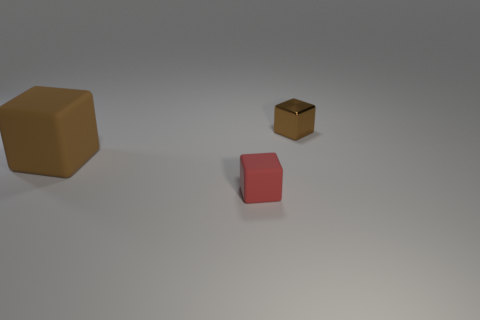Add 3 tiny red rubber objects. How many objects exist? 6 Subtract all red blocks. Subtract all brown cubes. How many objects are left? 0 Add 2 tiny red blocks. How many tiny red blocks are left? 3 Add 1 brown rubber cubes. How many brown rubber cubes exist? 2 Subtract 0 yellow cubes. How many objects are left? 3 